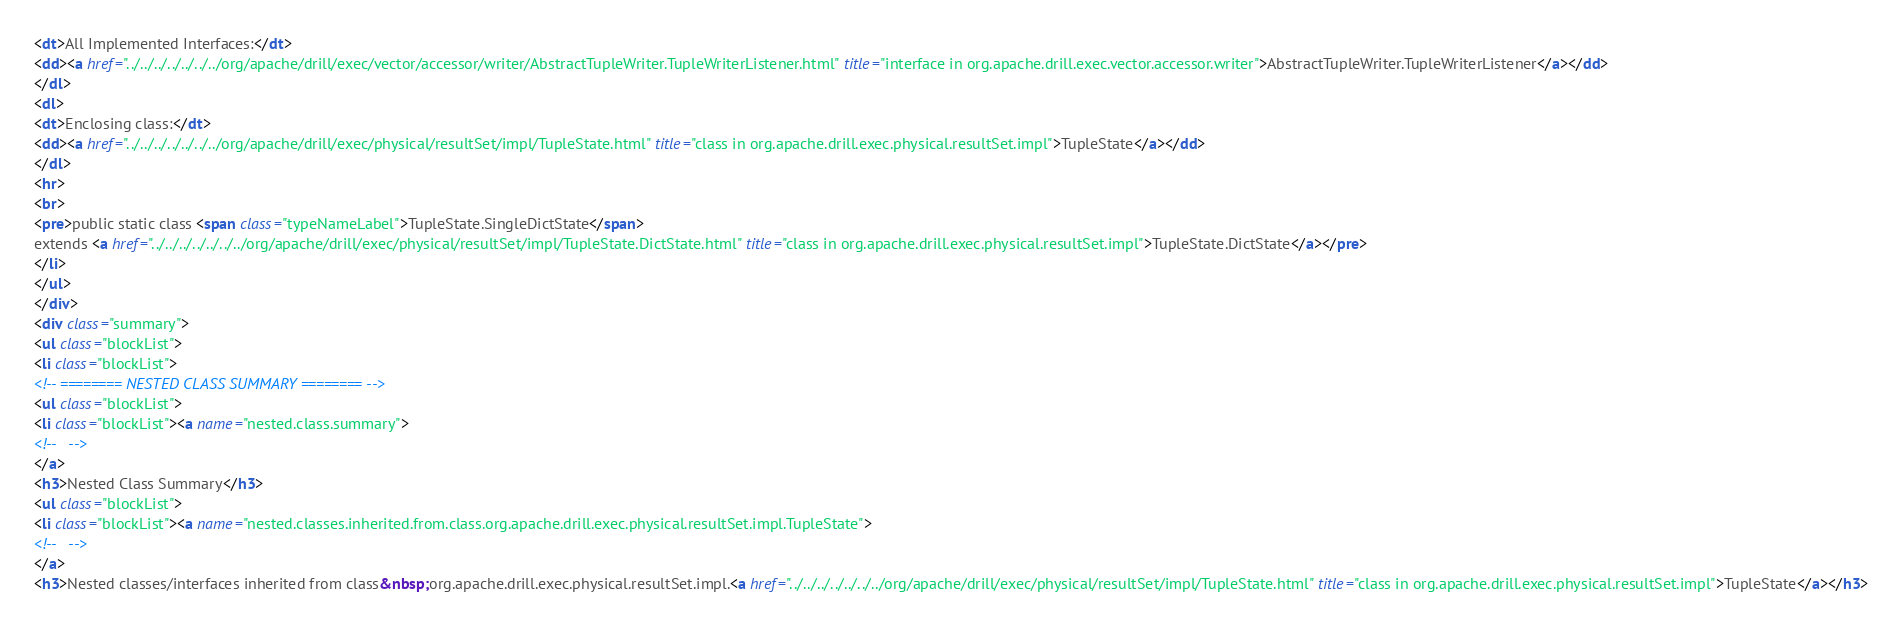<code> <loc_0><loc_0><loc_500><loc_500><_HTML_><dt>All Implemented Interfaces:</dt>
<dd><a href="../../../../../../../org/apache/drill/exec/vector/accessor/writer/AbstractTupleWriter.TupleWriterListener.html" title="interface in org.apache.drill.exec.vector.accessor.writer">AbstractTupleWriter.TupleWriterListener</a></dd>
</dl>
<dl>
<dt>Enclosing class:</dt>
<dd><a href="../../../../../../../org/apache/drill/exec/physical/resultSet/impl/TupleState.html" title="class in org.apache.drill.exec.physical.resultSet.impl">TupleState</a></dd>
</dl>
<hr>
<br>
<pre>public static class <span class="typeNameLabel">TupleState.SingleDictState</span>
extends <a href="../../../../../../../org/apache/drill/exec/physical/resultSet/impl/TupleState.DictState.html" title="class in org.apache.drill.exec.physical.resultSet.impl">TupleState.DictState</a></pre>
</li>
</ul>
</div>
<div class="summary">
<ul class="blockList">
<li class="blockList">
<!-- ======== NESTED CLASS SUMMARY ======== -->
<ul class="blockList">
<li class="blockList"><a name="nested.class.summary">
<!--   -->
</a>
<h3>Nested Class Summary</h3>
<ul class="blockList">
<li class="blockList"><a name="nested.classes.inherited.from.class.org.apache.drill.exec.physical.resultSet.impl.TupleState">
<!--   -->
</a>
<h3>Nested classes/interfaces inherited from class&nbsp;org.apache.drill.exec.physical.resultSet.impl.<a href="../../../../../../../org/apache/drill/exec/physical/resultSet/impl/TupleState.html" title="class in org.apache.drill.exec.physical.resultSet.impl">TupleState</a></h3></code> 